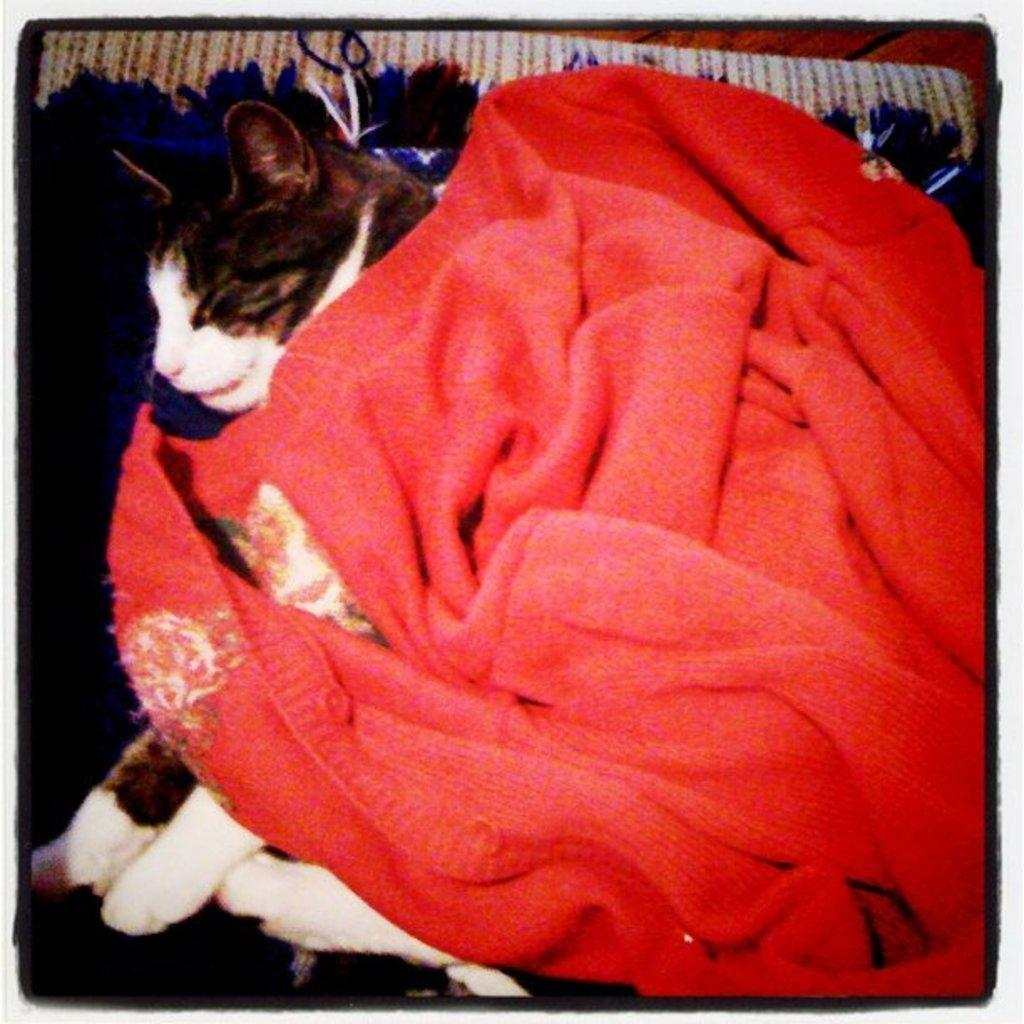What type of animal is in the image? There is a cat in the image. What object is on a tray in the image? There is a cloth on a tray in the image. What type of straw is the cat using to whistle in the image? There is no straw or whistling cat present in the image. 